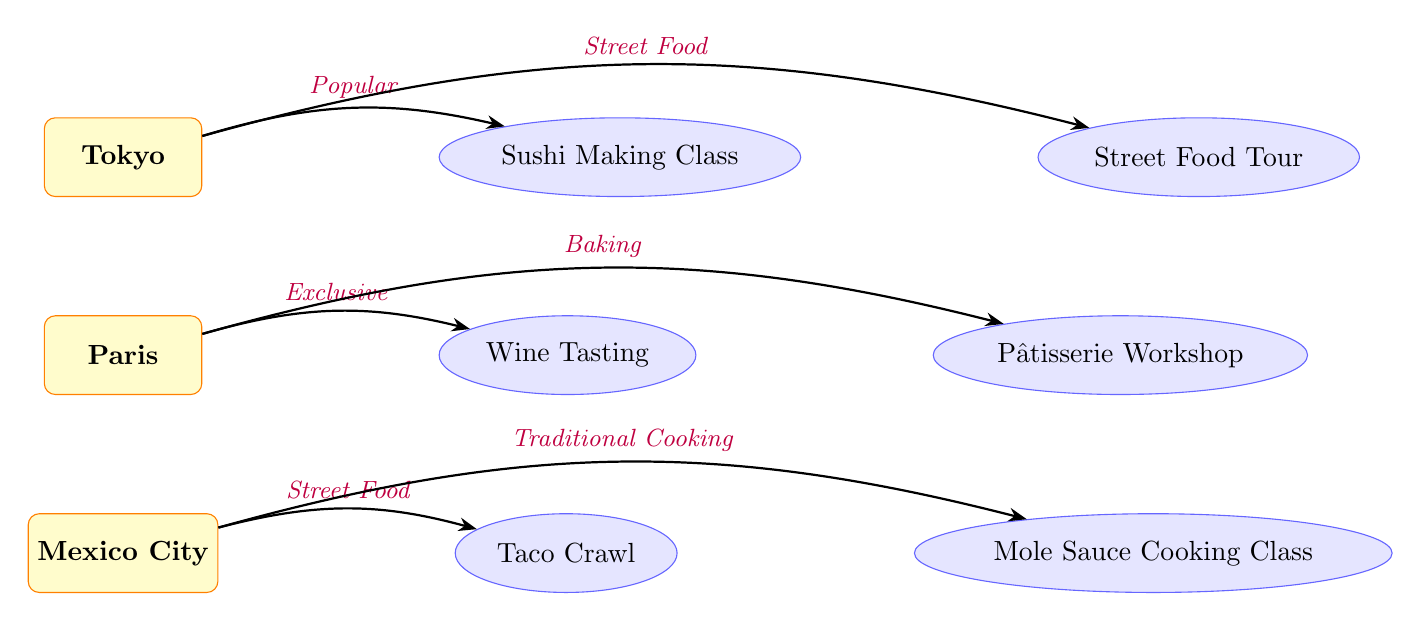What is the first culinary experience listed for Tokyo? The diagram shows "Sushi Making Class" as the first experience connected to the destination Tokyo via an edge labeled "Popular."
Answer: Sushi Making Class How many culinary experiences are recommended for Paris? There are two experiences labeled "Wine Tasting" and "Pâtisserie Workshop" that connect to the destination Paris, thus the total number is two.
Answer: 2 What type of culinary experience is associated with Mexico City that focuses on traditional cooking? The experience connected to Mexico City with an edge labeled "Traditional Cooking" is "Mole Sauce Cooking Class," which indicates it emphasizes traditional cooking methods.
Answer: Mole Sauce Cooking Class What is the relationship described between Tokyo and its Street Food Tour experience? The edge connecting Tokyo to the "Street Food Tour" is labeled "Street Food," indicating that this experience is specifically related to street food culture in Tokyo.
Answer: Street Food Which destination has an exclusive culinary experience? The "Wine Tasting" experience connected to Paris is labeled "Exclusive," indicating that it is a unique offering at this destination.
Answer: Paris How many edges are connecting culinary experiences to destinations in total? Counting the edges from Tokyo to its experiences (2), from Paris to its experiences (2), and from Mexico City to its experiences (2), the total number of edges amounts to six.
Answer: 6 What is the second culinary experience listed for Mexico City? The second experience connected to Mexico City is "Mole Sauce Cooking Class," which follows the "Taco Crawl" experience in the flow of the diagram.
Answer: Mole Sauce Cooking Class What type of experience does the edge from Paris to Pâtisserie Workshop indicate? The edge from Paris to the "Pâtisserie Workshop" is labeled "Baking," which defines the type of experience as a baking-focused culinary workshop.
Answer: Baking What are the two culinary experiences listed for Tokyo? For Tokyo, the experiences are "Sushi Making Class" and "Street Food Tour," which are connected to the destination through distinct edges.
Answer: Sushi Making Class, Street Food Tour 